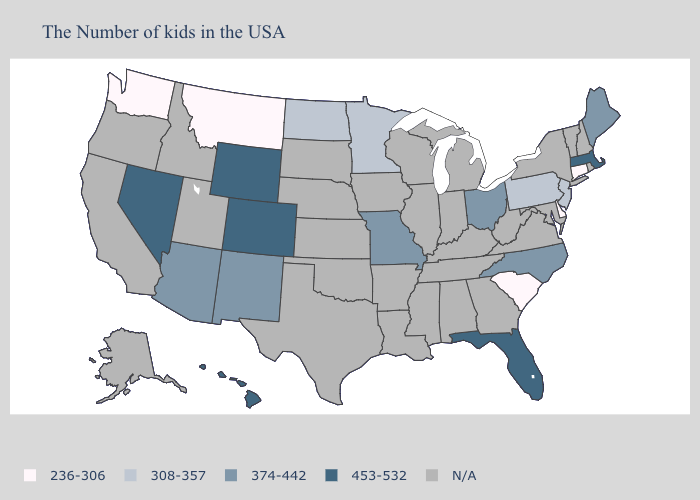What is the lowest value in the MidWest?
Short answer required. 308-357. Name the states that have a value in the range 374-442?
Short answer required. Maine, North Carolina, Ohio, Missouri, New Mexico, Arizona. Does Pennsylvania have the lowest value in the USA?
Be succinct. No. What is the value of New Jersey?
Answer briefly. 308-357. What is the value of Mississippi?
Concise answer only. N/A. Does Washington have the lowest value in the West?
Short answer required. Yes. Which states have the highest value in the USA?
Short answer required. Massachusetts, Florida, Wyoming, Colorado, Nevada, Hawaii. Name the states that have a value in the range 308-357?
Write a very short answer. New Jersey, Pennsylvania, Minnesota, North Dakota. Name the states that have a value in the range 453-532?
Give a very brief answer. Massachusetts, Florida, Wyoming, Colorado, Nevada, Hawaii. Name the states that have a value in the range N/A?
Give a very brief answer. Rhode Island, New Hampshire, Vermont, New York, Maryland, Virginia, West Virginia, Georgia, Michigan, Kentucky, Indiana, Alabama, Tennessee, Wisconsin, Illinois, Mississippi, Louisiana, Arkansas, Iowa, Kansas, Nebraska, Oklahoma, Texas, South Dakota, Utah, Idaho, California, Oregon, Alaska. Name the states that have a value in the range 453-532?
Keep it brief. Massachusetts, Florida, Wyoming, Colorado, Nevada, Hawaii. Which states have the lowest value in the Northeast?
Answer briefly. Connecticut. What is the lowest value in states that border Wyoming?
Keep it brief. 236-306. Name the states that have a value in the range 453-532?
Short answer required. Massachusetts, Florida, Wyoming, Colorado, Nevada, Hawaii. 